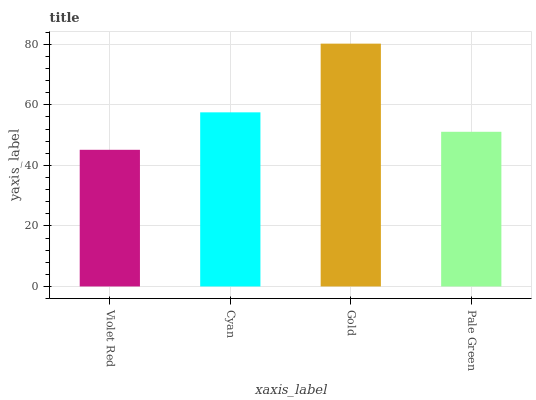Is Violet Red the minimum?
Answer yes or no. Yes. Is Gold the maximum?
Answer yes or no. Yes. Is Cyan the minimum?
Answer yes or no. No. Is Cyan the maximum?
Answer yes or no. No. Is Cyan greater than Violet Red?
Answer yes or no. Yes. Is Violet Red less than Cyan?
Answer yes or no. Yes. Is Violet Red greater than Cyan?
Answer yes or no. No. Is Cyan less than Violet Red?
Answer yes or no. No. Is Cyan the high median?
Answer yes or no. Yes. Is Pale Green the low median?
Answer yes or no. Yes. Is Violet Red the high median?
Answer yes or no. No. Is Cyan the low median?
Answer yes or no. No. 